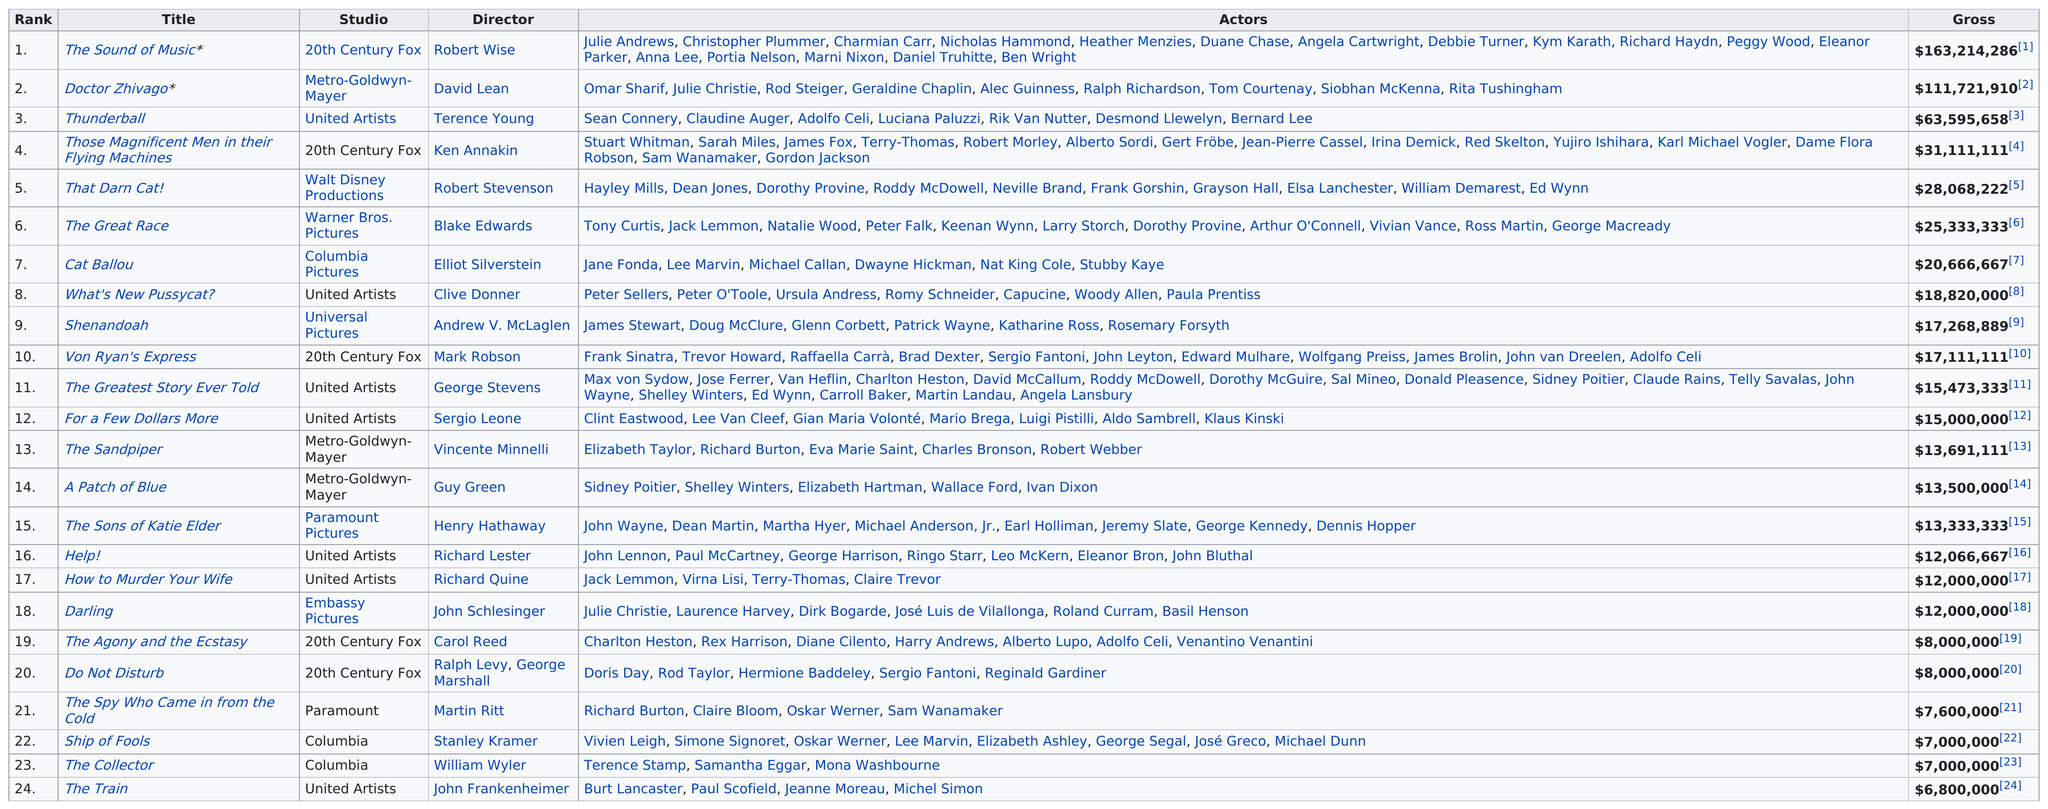Outline some significant characteristics in this image. Twenty-first Century Fox appears 5 times on the list of top-grossing films in the United States. The Sandpiper, a 1965 film, starred actors Elizabeth Taylor and Richard Burton. Robert Wise was the most successful and highly grossing director of 1965. The Train, which is considered the least successful of the five films in the series, is a suspenseful and dramatic heist film. The Sound of Music is the film that had the best rank. 